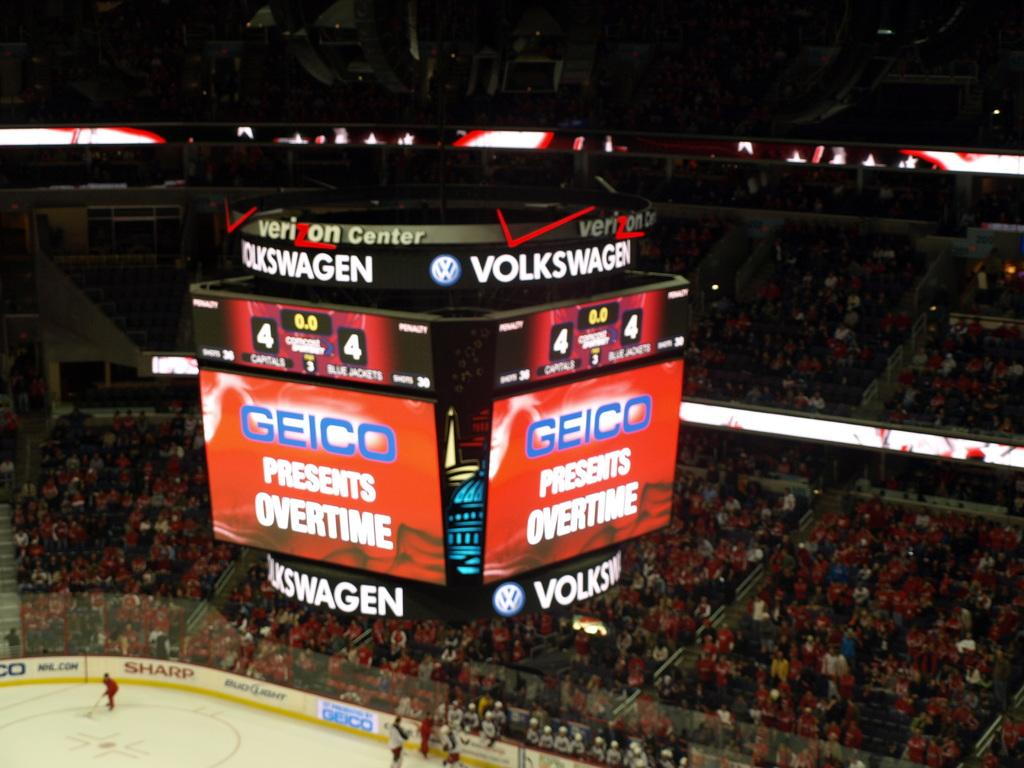<image>
Present a compact description of the photo's key features. a scoreboard that has the word Geico on it 